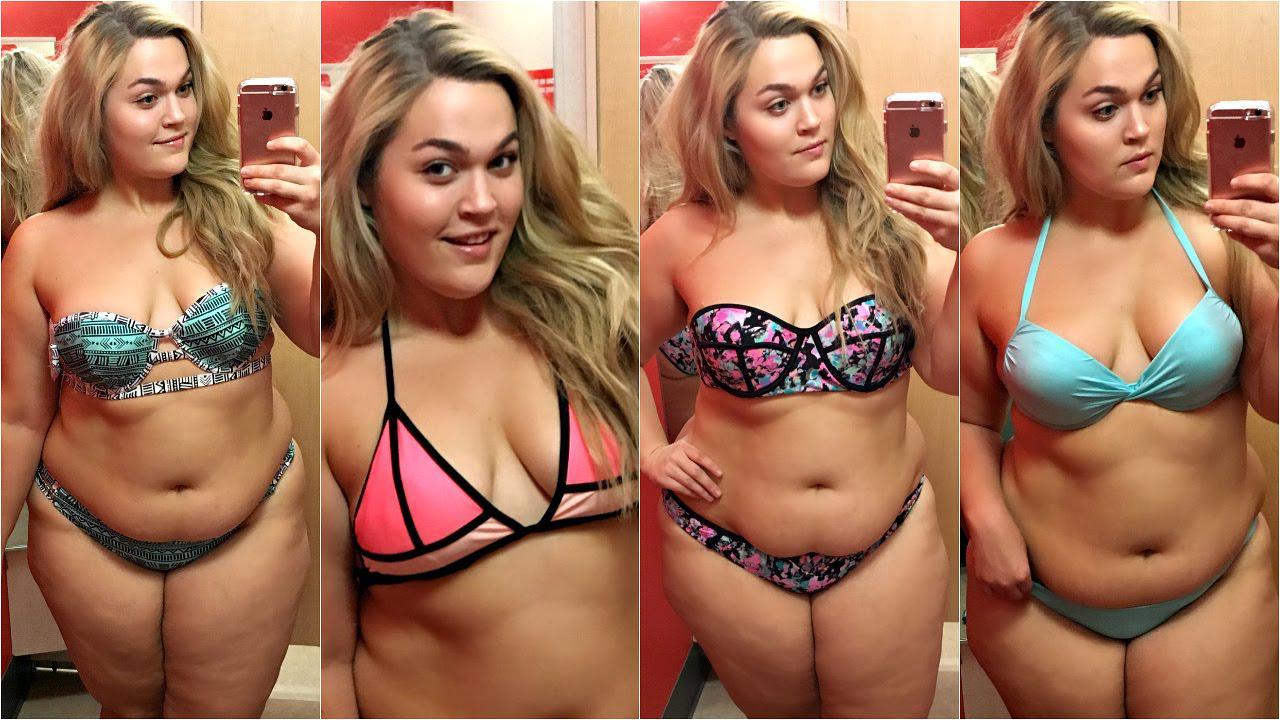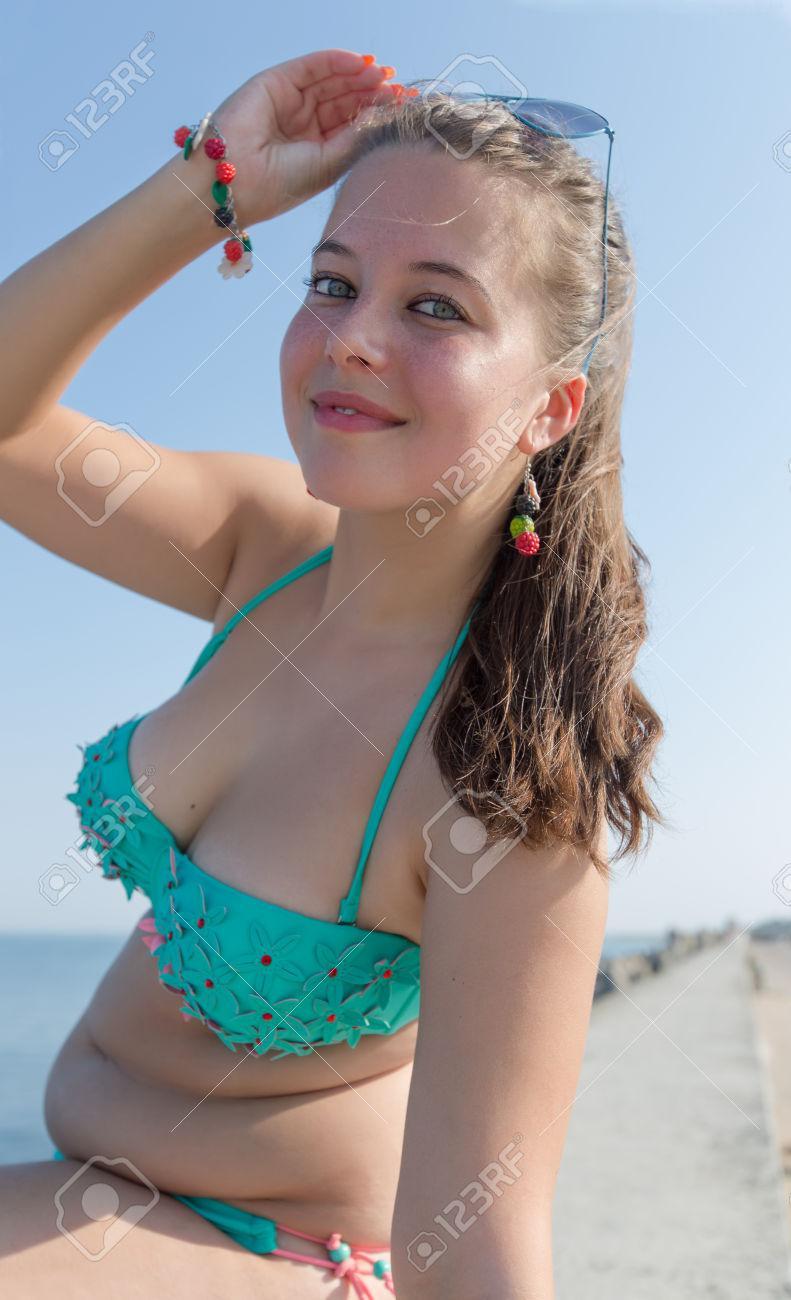The first image is the image on the left, the second image is the image on the right. Given the left and right images, does the statement "There are five women in two pieces suits." hold true? Answer yes or no. Yes. 